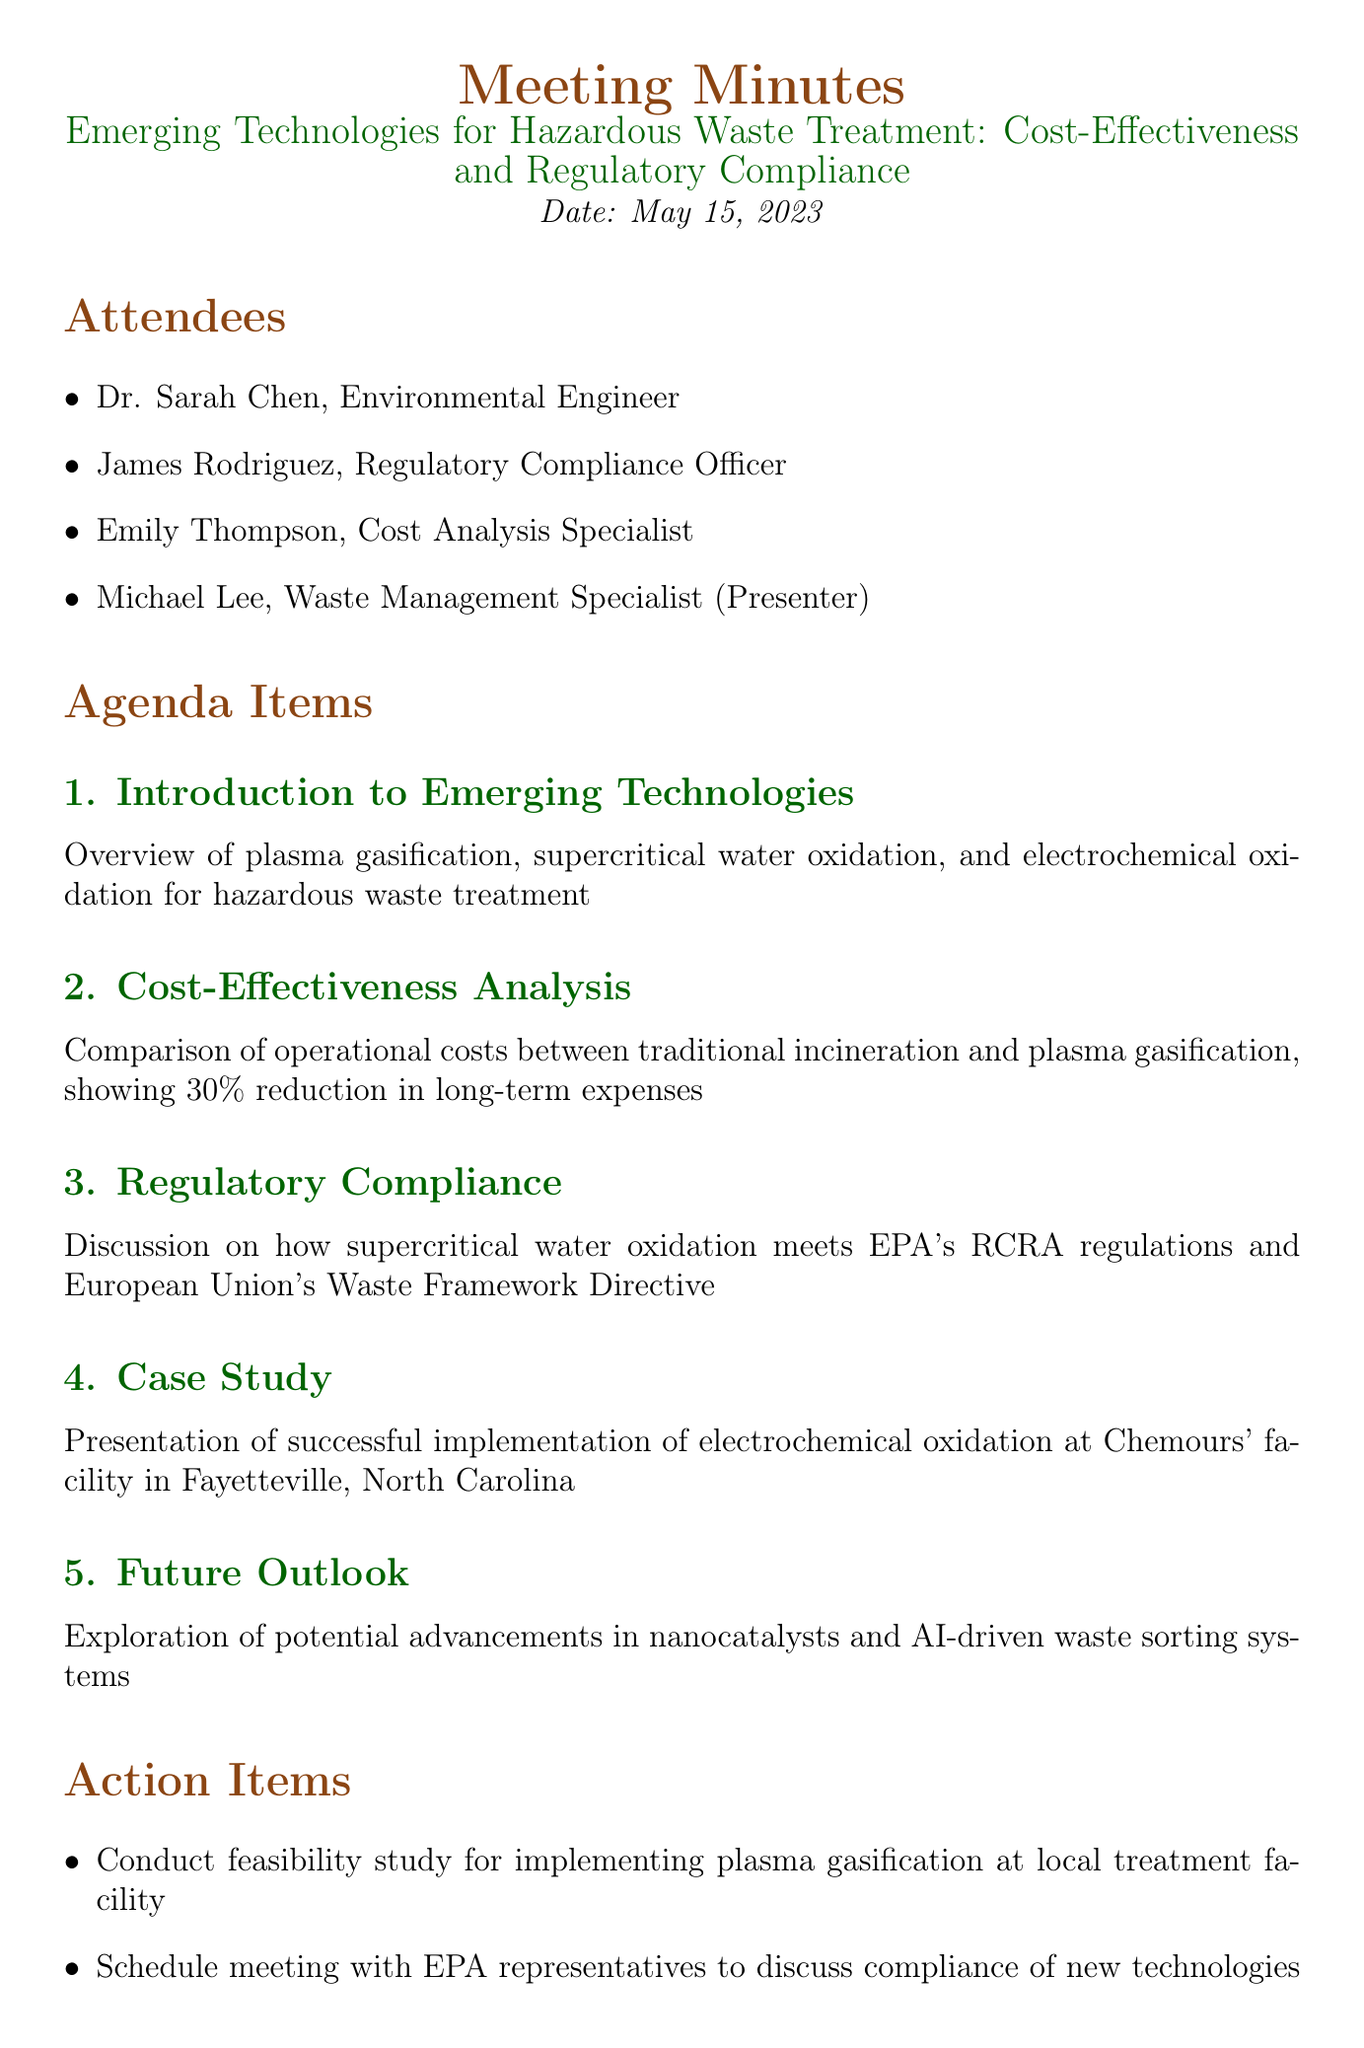What is the meeting title? The meeting title is stated at the top of the document, identifying the main focus of discussion.
Answer: Emerging Technologies for Hazardous Waste Treatment: Cost-Effectiveness and Regulatory Compliance Who presented at the meeting? The document lists attendees, including the role of the presenter.
Answer: Michael Lee What date was the meeting held? The date is explicitly mentioned in the document, indicating when the meeting took place.
Answer: May 15, 2023 How much reduction in long-term expenses does plasma gasification provide compared to traditional incineration? The cost-effectiveness analysis section describes the operational cost comparison, highlighting the percentage reduction.
Answer: 30% Which technology meets EPA's RCRA regulations? The regulatory compliance section specifically mentions the technology that adheres to these regulations.
Answer: Supercritical water oxidation What is the next meeting date? The next meeting date is noted at the bottom of the document, indicating when the follow-up meeting is scheduled.
Answer: June 15, 2023 What action item involves the EPA? The document outlines action items that include specific discussions related to regulatory compliance.
Answer: Schedule meeting with EPA representatives to discuss compliance of new technologies Where was the case study implemented? The case study section specifies the location of the successful implementation of a technology.
Answer: Fayetteville, North Carolina What are the potential future advancements discussed? The future outlook section mentions specific advancements that are anticipated in the field of hazardous waste treatment.
Answer: Nanocatalysts and AI-driven waste sorting systems 